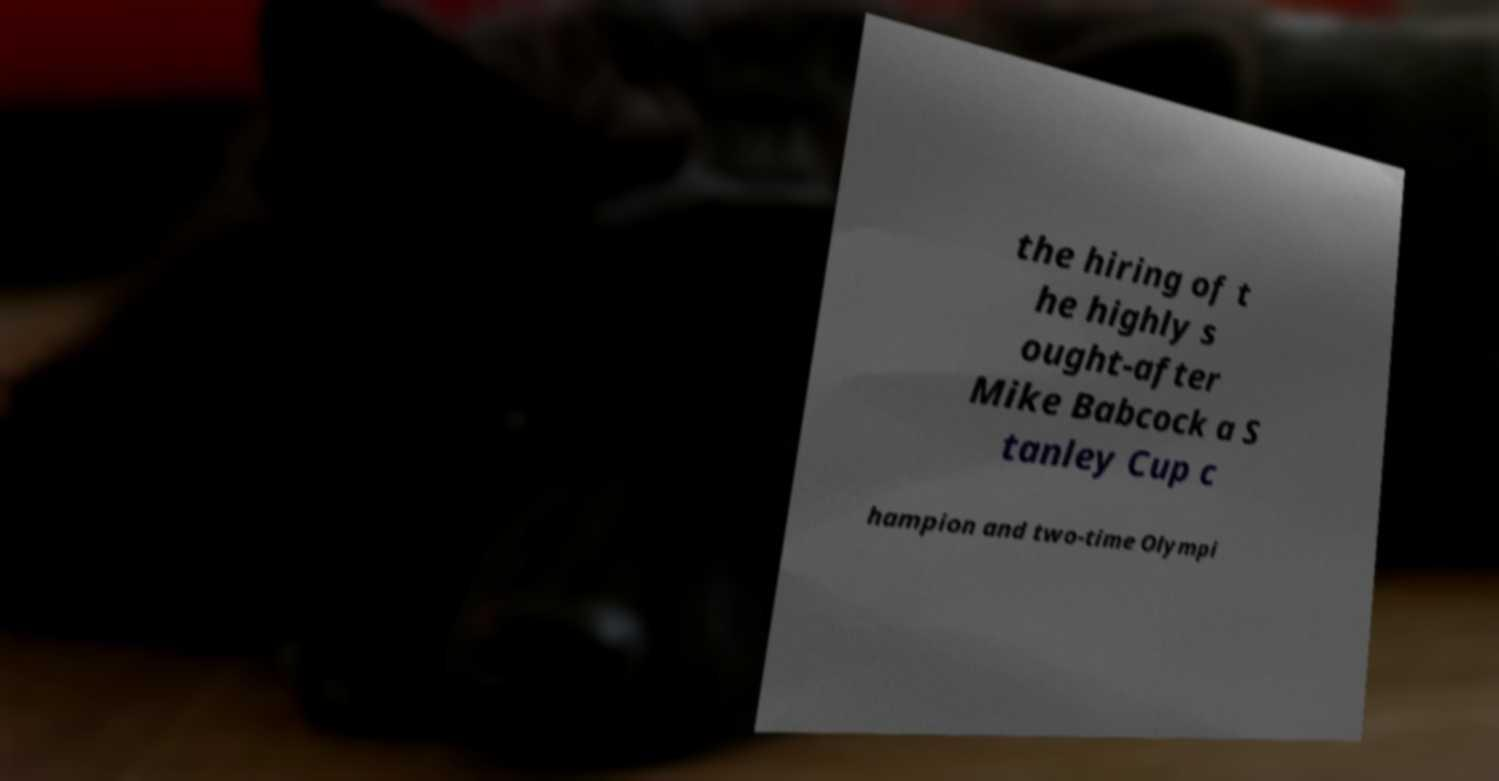Could you extract and type out the text from this image? the hiring of t he highly s ought-after Mike Babcock a S tanley Cup c hampion and two-time Olympi 